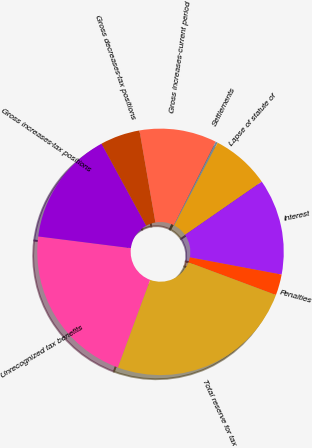<chart> <loc_0><loc_0><loc_500><loc_500><pie_chart><fcel>Unrecognized tax benefits<fcel>Gross increases-tax positions<fcel>Gross decreases-tax positions<fcel>Gross increases-current period<fcel>Settlements<fcel>Lapse of statute of<fcel>Interest<fcel>Penalties<fcel>Total reserve for tax<nl><fcel>21.39%<fcel>15.06%<fcel>5.21%<fcel>10.13%<fcel>0.28%<fcel>7.67%<fcel>12.6%<fcel>2.74%<fcel>24.92%<nl></chart> 